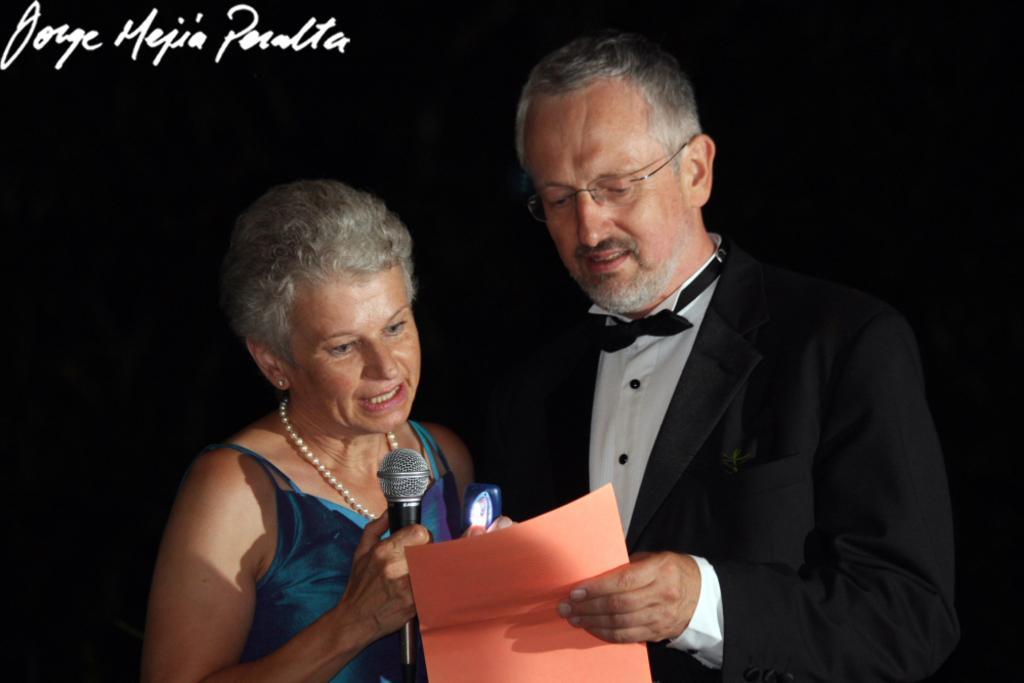How would you summarize this image in a sentence or two? In this image I can see two people. One person is holding the mic and another person is holding the paper. 